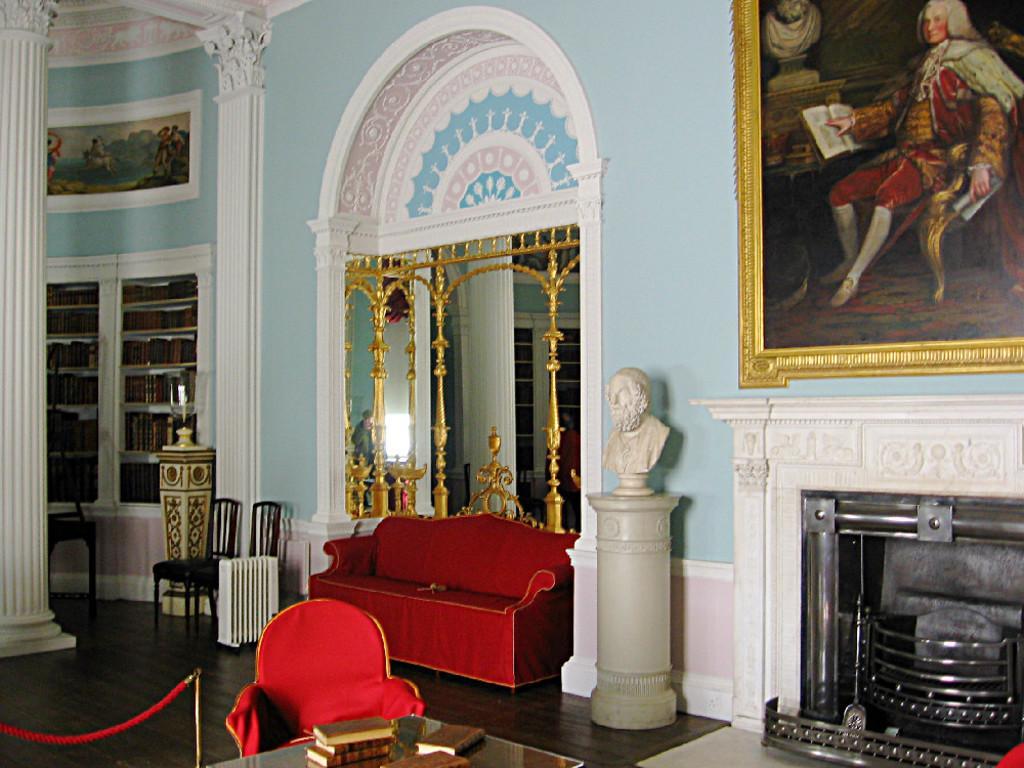Describe this image in one or two sentences. In middle of this picture, we see a red sofa. To the right of it, we see a statue placed on the pillar. In middle, in front, we see a table on which books are placed, and a red color chair. On background, we see chairs two chairs and the rack is filled with books and on the left corner, we see pillar. Behind that we see a wall on which photo frame is placed on it. to the right top, we see photo frame of man sitting on the chair and he is holding book in his hand. 